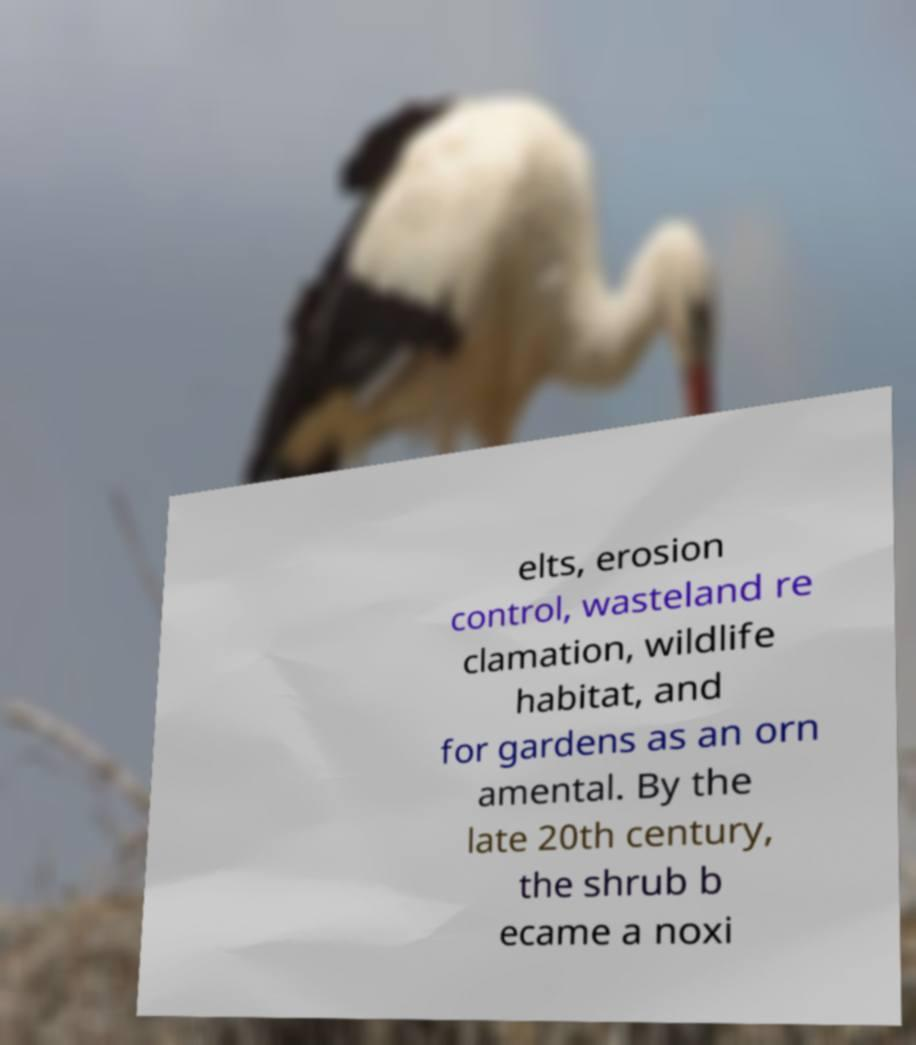Please read and relay the text visible in this image. What does it say? elts, erosion control, wasteland re clamation, wildlife habitat, and for gardens as an orn amental. By the late 20th century, the shrub b ecame a noxi 